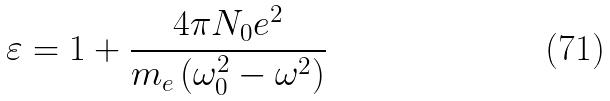<formula> <loc_0><loc_0><loc_500><loc_500>\varepsilon = 1 + \frac { 4 \pi N _ { 0 } e ^ { 2 } } { m _ { e } \left ( \omega ^ { 2 } _ { 0 } - \omega ^ { 2 } \right ) }</formula> 